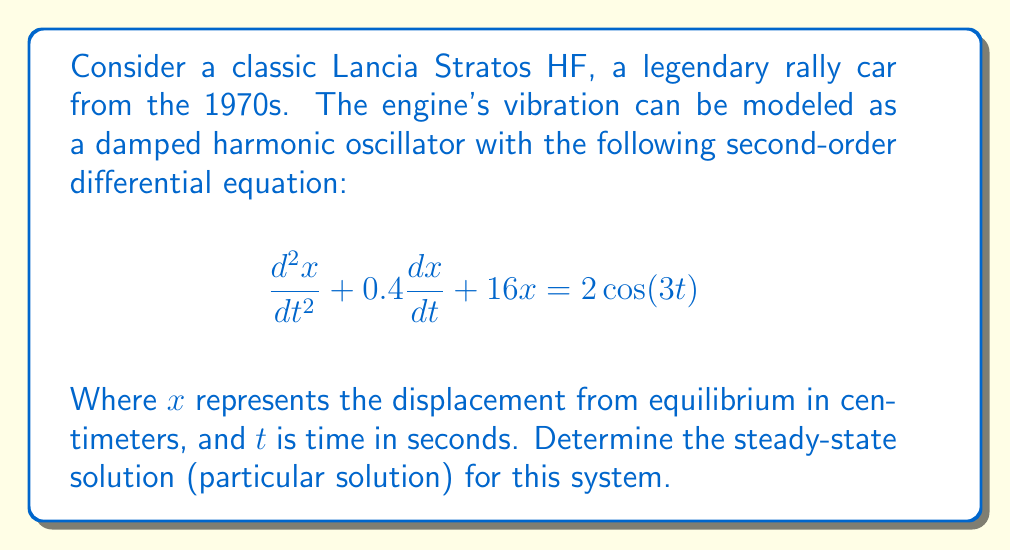Show me your answer to this math problem. To find the steady-state solution, we need to follow these steps:

1) The general form of the particular solution for a forced oscillation with cosine forcing is:
   $$x_p(t) = A\cos(3t) + B\sin(3t)$$

2) We need to find the values of A and B. To do this, we substitute $x_p(t)$ into the original differential equation:

   $$-9A\cos(3t) - 9B\sin(3t) + 1.2A\sin(3t) - 1.2B\cos(3t) + 16A\cos(3t) + 16B\sin(3t) = 2\cos(3t)$$

3) Grouping the coefficients of $\cos(3t)$ and $\sin(3t)$:

   $$(16A - 9A - 1.2B)\cos(3t) + (16B - 9B + 1.2A)\sin(3t) = 2\cos(3t)$$

4) This leads to two equations:
   $$7A - 1.2B = 2$$
   $$1.2A + 7B = 0$$

5) Solving this system of equations:
   Multiply the second equation by 7 and the first by 1.2:
   $$8.4A + 49B = 0$$
   $$8.4A - 1.44B = 2.4$$
   
   Subtracting these equations:
   $$50.44B = -2.4$$
   $$B = -0.0476$$

   Substituting this back into $1.2A + 7B = 0$:
   $$1.2A - 0.3332 = 0$$
   $$A = 0.2777$$

6) Therefore, the steady-state solution is:
   $$x_p(t) = 0.2777\cos(3t) - 0.0476\sin(3t)$$

This represents the long-term behavior of the Lancia Stratos HF's engine vibration under the given conditions.
Answer: $$x_p(t) = 0.2777\cos(3t) - 0.0476\sin(3t)$$ 